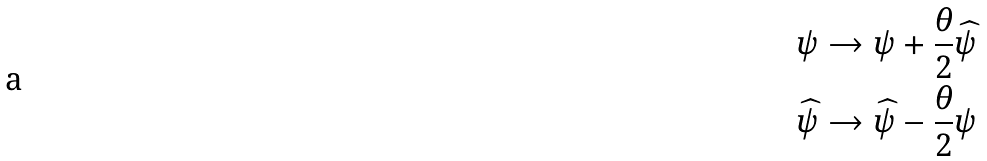Convert formula to latex. <formula><loc_0><loc_0><loc_500><loc_500>\psi & \rightarrow \psi + \frac { \theta } { 2 } \widehat { \psi } \\ \widehat { \psi } & \rightarrow \widehat { \psi } - \frac { \theta } { 2 } \psi</formula> 